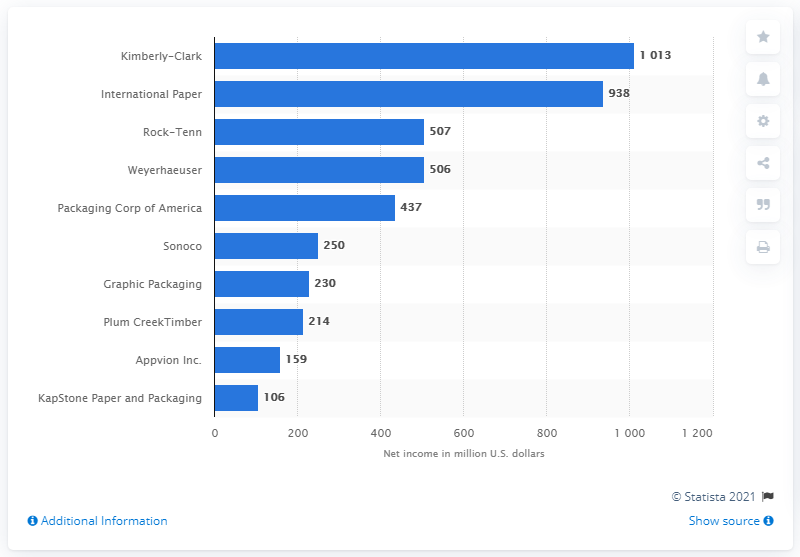Specify some key components in this picture. Kimberly-Clark's net income in dollars for the year 2015 was 101,300. 